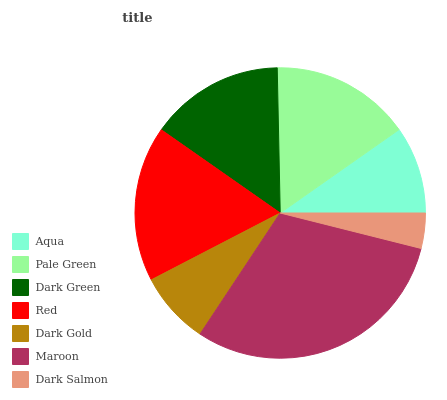Is Dark Salmon the minimum?
Answer yes or no. Yes. Is Maroon the maximum?
Answer yes or no. Yes. Is Pale Green the minimum?
Answer yes or no. No. Is Pale Green the maximum?
Answer yes or no. No. Is Pale Green greater than Aqua?
Answer yes or no. Yes. Is Aqua less than Pale Green?
Answer yes or no. Yes. Is Aqua greater than Pale Green?
Answer yes or no. No. Is Pale Green less than Aqua?
Answer yes or no. No. Is Dark Green the high median?
Answer yes or no. Yes. Is Dark Green the low median?
Answer yes or no. Yes. Is Maroon the high median?
Answer yes or no. No. Is Dark Gold the low median?
Answer yes or no. No. 